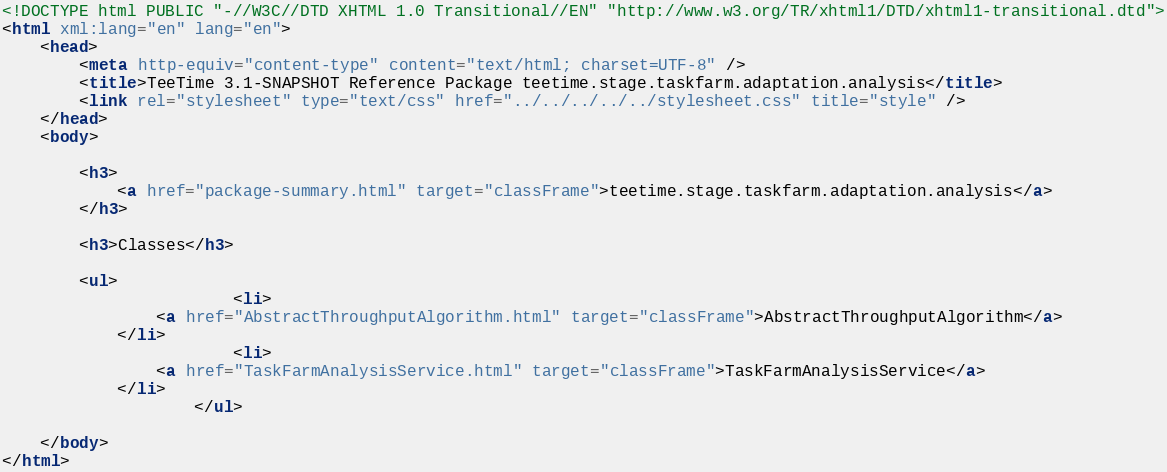<code> <loc_0><loc_0><loc_500><loc_500><_HTML_>
<!DOCTYPE html PUBLIC "-//W3C//DTD XHTML 1.0 Transitional//EN" "http://www.w3.org/TR/xhtml1/DTD/xhtml1-transitional.dtd">
<html xml:lang="en" lang="en">
	<head>
		<meta http-equiv="content-type" content="text/html; charset=UTF-8" />
		<title>TeeTime 3.1-SNAPSHOT Reference Package teetime.stage.taskfarm.adaptation.analysis</title>
		<link rel="stylesheet" type="text/css" href="../../../../../stylesheet.css" title="style" />
	</head>
	<body>

		<h3>
        	<a href="package-summary.html" target="classFrame">teetime.stage.taskfarm.adaptation.analysis</a>
      	</h3>

      	<h3>Classes</h3>

      	<ul>
      		          	<li>
            	<a href="AbstractThroughputAlgorithm.html" target="classFrame">AbstractThroughputAlgorithm</a>
          	</li>
          	          	<li>
            	<a href="TaskFarmAnalysisService.html" target="classFrame">TaskFarmAnalysisService</a>
          	</li>
          	      	</ul>

	</body>
</html></code> 